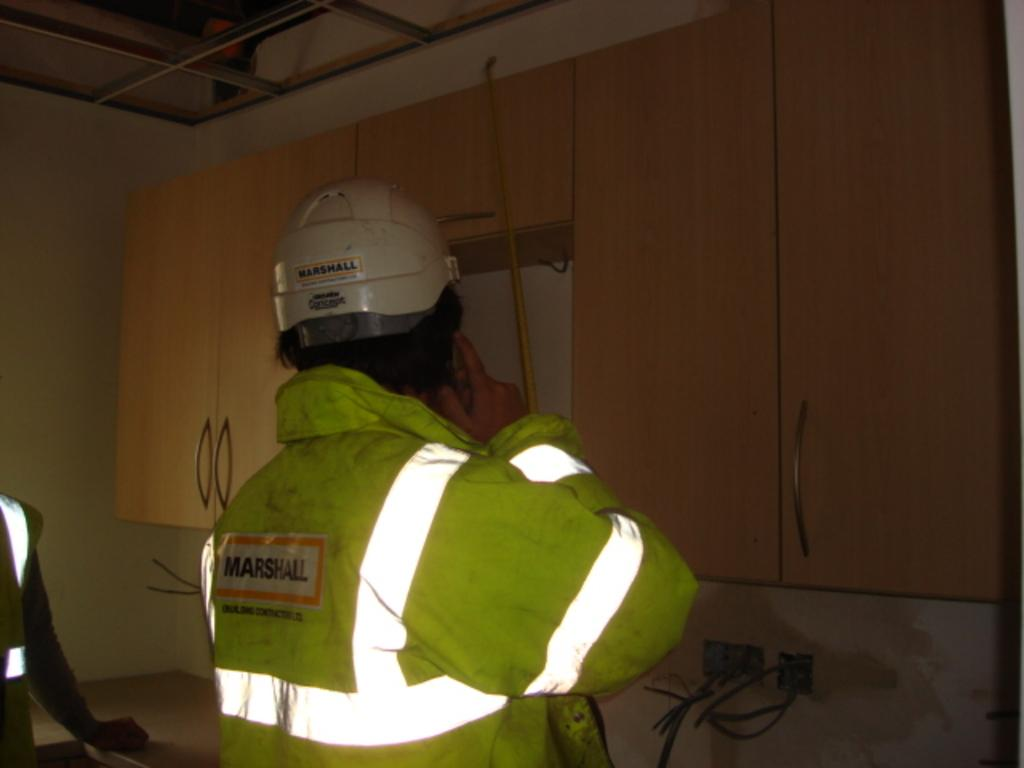How many people are in the image? There are two people in the image. What type of furniture can be seen in the image? There are cupboards in the image. What is one person wearing that is not typical for everyday wear? One person is wearing a helmet. How would you describe the lighting in the image? The image is dark. What type of hook is being used by the person wearing the helmet in the image? There is no hook present in the image; the person is wearing a helmet, but no hook is visible or mentioned in the provided facts. 